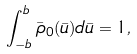Convert formula to latex. <formula><loc_0><loc_0><loc_500><loc_500>\int _ { - b } ^ { b } \bar { \rho } _ { 0 } ( \bar { u } ) d \bar { u } = 1 ,</formula> 